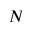Convert formula to latex. <formula><loc_0><loc_0><loc_500><loc_500>N</formula> 